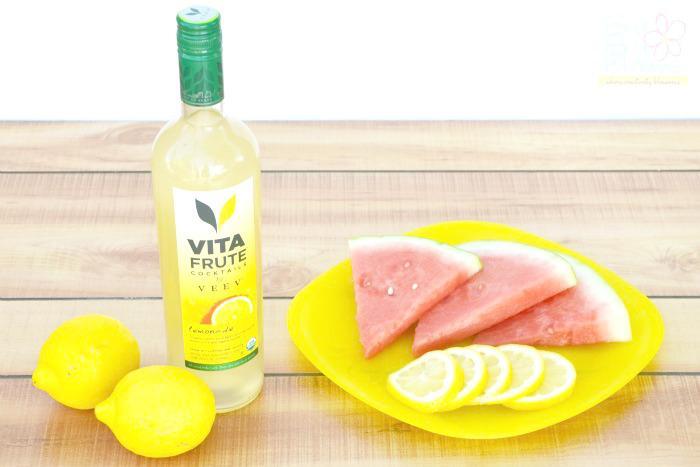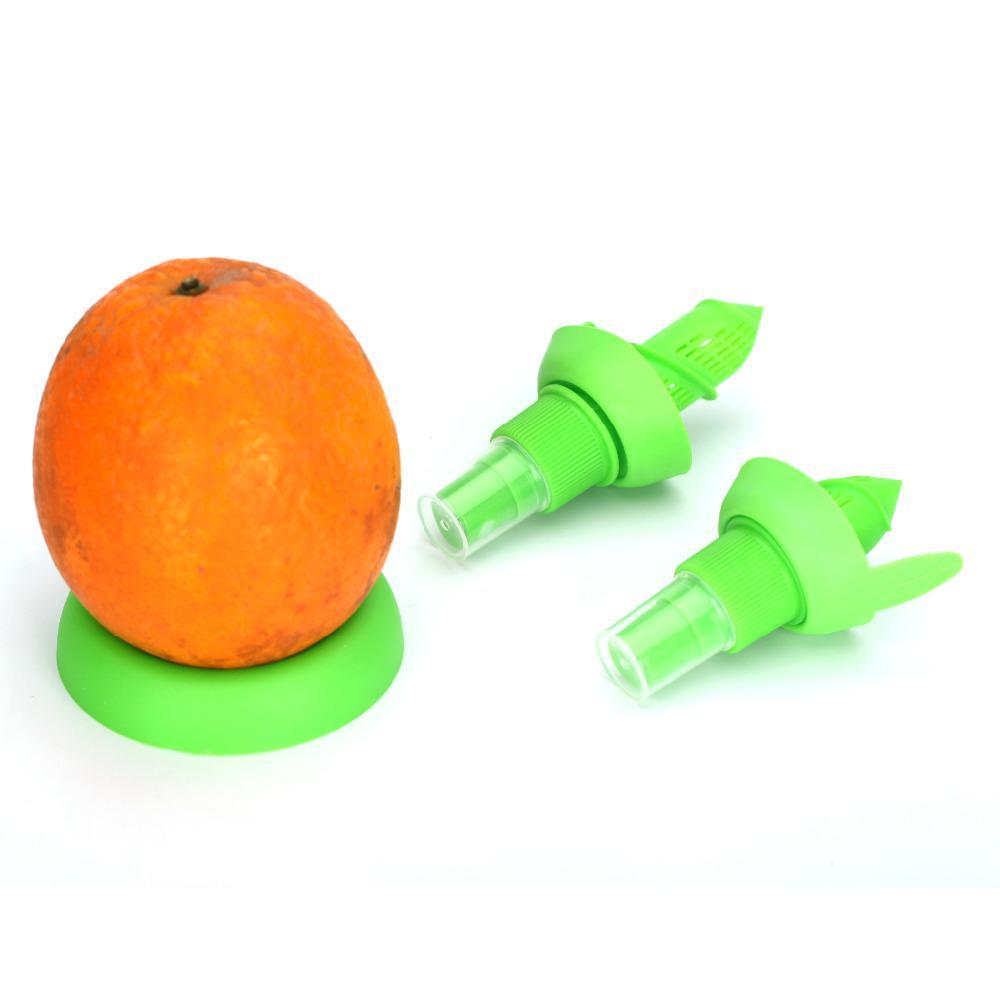The first image is the image on the left, the second image is the image on the right. Assess this claim about the two images: "An image contains a lemon being sliced by a knife.". Correct or not? Answer yes or no. No. The first image is the image on the left, the second image is the image on the right. Evaluate the accuracy of this statement regarding the images: "In one of the images, a whole lemon is being cut with a knife.". Is it true? Answer yes or no. No. 